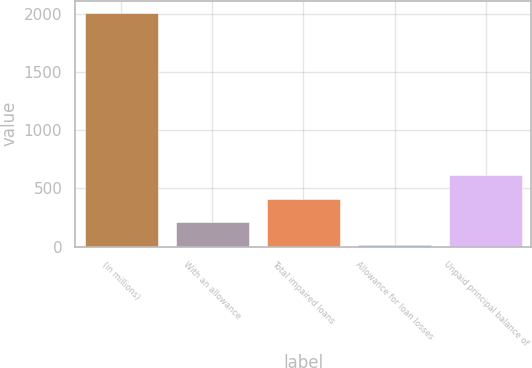Convert chart. <chart><loc_0><loc_0><loc_500><loc_500><bar_chart><fcel>(in millions)<fcel>With an allowance<fcel>Total impaired loans<fcel>Allowance for loan losses<fcel>Unpaid principal balance of<nl><fcel>2010<fcel>213.6<fcel>413.2<fcel>14<fcel>612.8<nl></chart> 